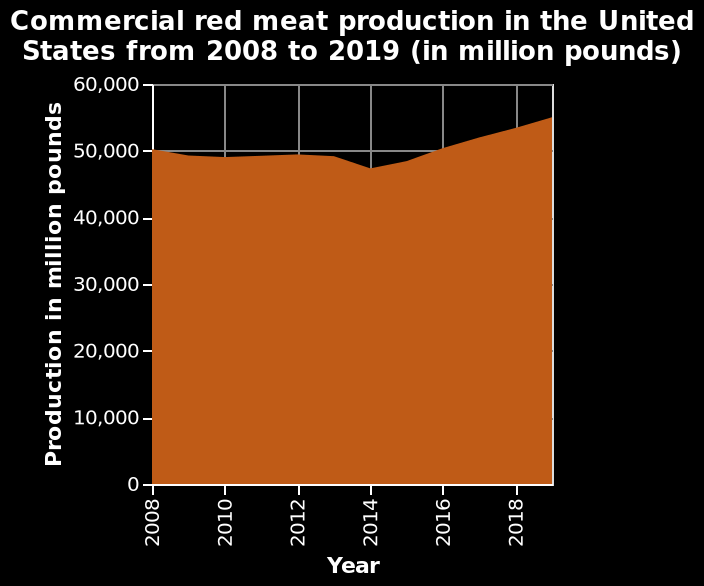<image>
What is the maximum year represented on the x-axis? The maximum year represented on the x-axis is 2018. What is the range on the x-axis of the graph?  The x-axis of the graph has a linear scale ranging from 2008 to 2018. please summary the statistics and relations of the chart Between 2008-2013 production stays at a relatively steady value, approximately 49,000 million pounds. Between 2014-2019 there is an increase from approximately 48,000 to 55,000 million pounds. Between 2013-2014 there is there was the only major drop in production of approximately 1,000 millions pounds. What was the change in production from 2014-2019? The production increased from approximately 48,000 to 55,000 million pounds from 2014-2019. When was the only major drop in production? The only major drop in production was between 2013-2014. 